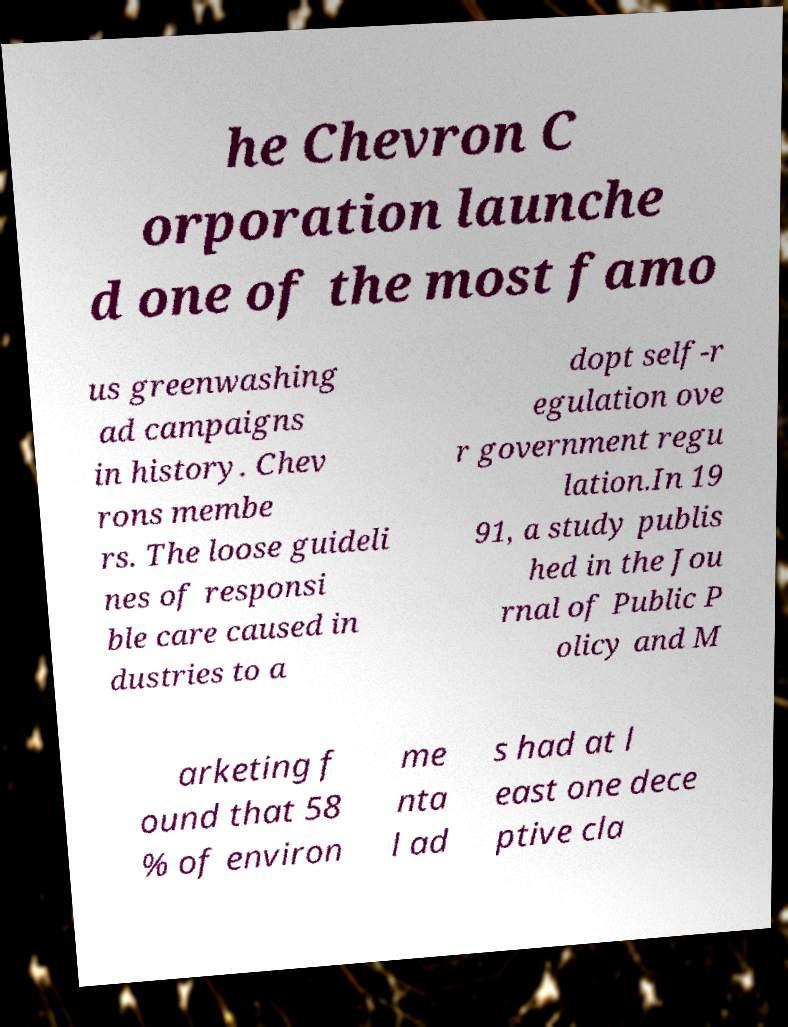Can you read and provide the text displayed in the image?This photo seems to have some interesting text. Can you extract and type it out for me? he Chevron C orporation launche d one of the most famo us greenwashing ad campaigns in history. Chev rons membe rs. The loose guideli nes of responsi ble care caused in dustries to a dopt self-r egulation ove r government regu lation.In 19 91, a study publis hed in the Jou rnal of Public P olicy and M arketing f ound that 58 % of environ me nta l ad s had at l east one dece ptive cla 